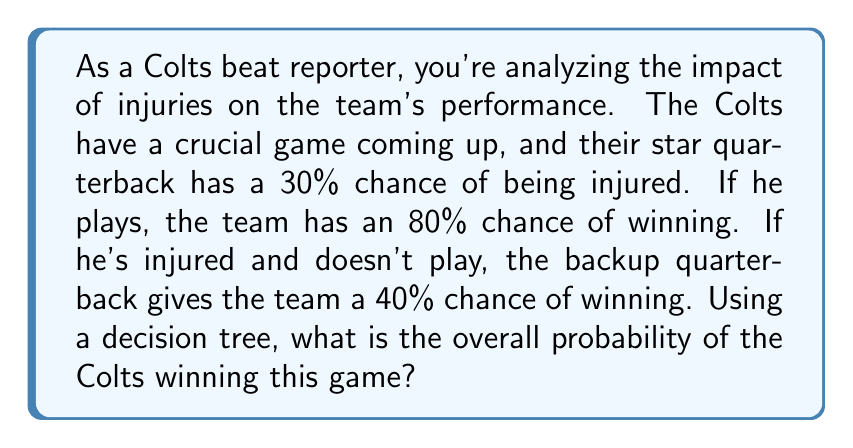Help me with this question. Let's approach this problem using a decision tree:

1. First, we need to identify the two main branches of our decision tree:
   - Star quarterback plays (70% chance)
   - Star quarterback is injured (30% chance)

2. For each of these branches, we have the probability of winning:
   - If star QB plays: 80% chance of winning
   - If star QB is injured: 40% chance of winning with backup QB

3. Now, let's calculate the probability of winning for each scenario:
   
   a) Probability of winning with star QB:
      $P(\text{Win with Star QB}) = 0.70 \times 0.80 = 0.56$ or 56%
   
   b) Probability of winning with backup QB:
      $P(\text{Win with Backup QB}) = 0.30 \times 0.40 = 0.12$ or 12%

4. To get the overall probability of winning, we sum these two probabilities:

   $P(\text{Win overall}) = P(\text{Win with Star QB}) + P(\text{Win with Backup QB})$
   $P(\text{Win overall}) = 0.56 + 0.12 = 0.68$

Therefore, the overall probability of the Colts winning this game is 0.68 or 68%.

[asy]
import geometry;

size(200);

pair A = (0,0);
pair B1 = (100,50);
pair B2 = (100,-50);
pair C1 = (200,75);
pair C2 = (200,25);
pair C3 = (200,-25);
pair C4 = (200,-75);

draw(A--B1--C1);
draw(A--B1--C2);
draw(A--B2--C3);
draw(A--B2--C4);

label("Start", A, W);
label("70%", (A+B1)/2, NW);
label("30%", (A+B2)/2, SW);
label("80%", (B1+C1)/2, N);
label("20%", (B1+C2)/2, S);
label("40%", (B2+C3)/2, N);
label("60%", (B2+C4)/2, S);

label("Star QB plays", B1, E);
label("Star QB injured", B2, E);
label("Win", C1, E);
label("Lose", C2, E);
label("Win", C3, E);
label("Lose", C4, E);
[/asy]
Answer: The overall probability of the Colts winning the game is 68%. 